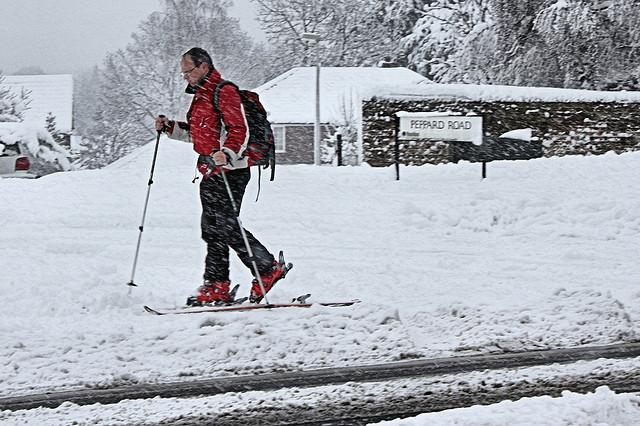What caused the lines in the snow? tires 